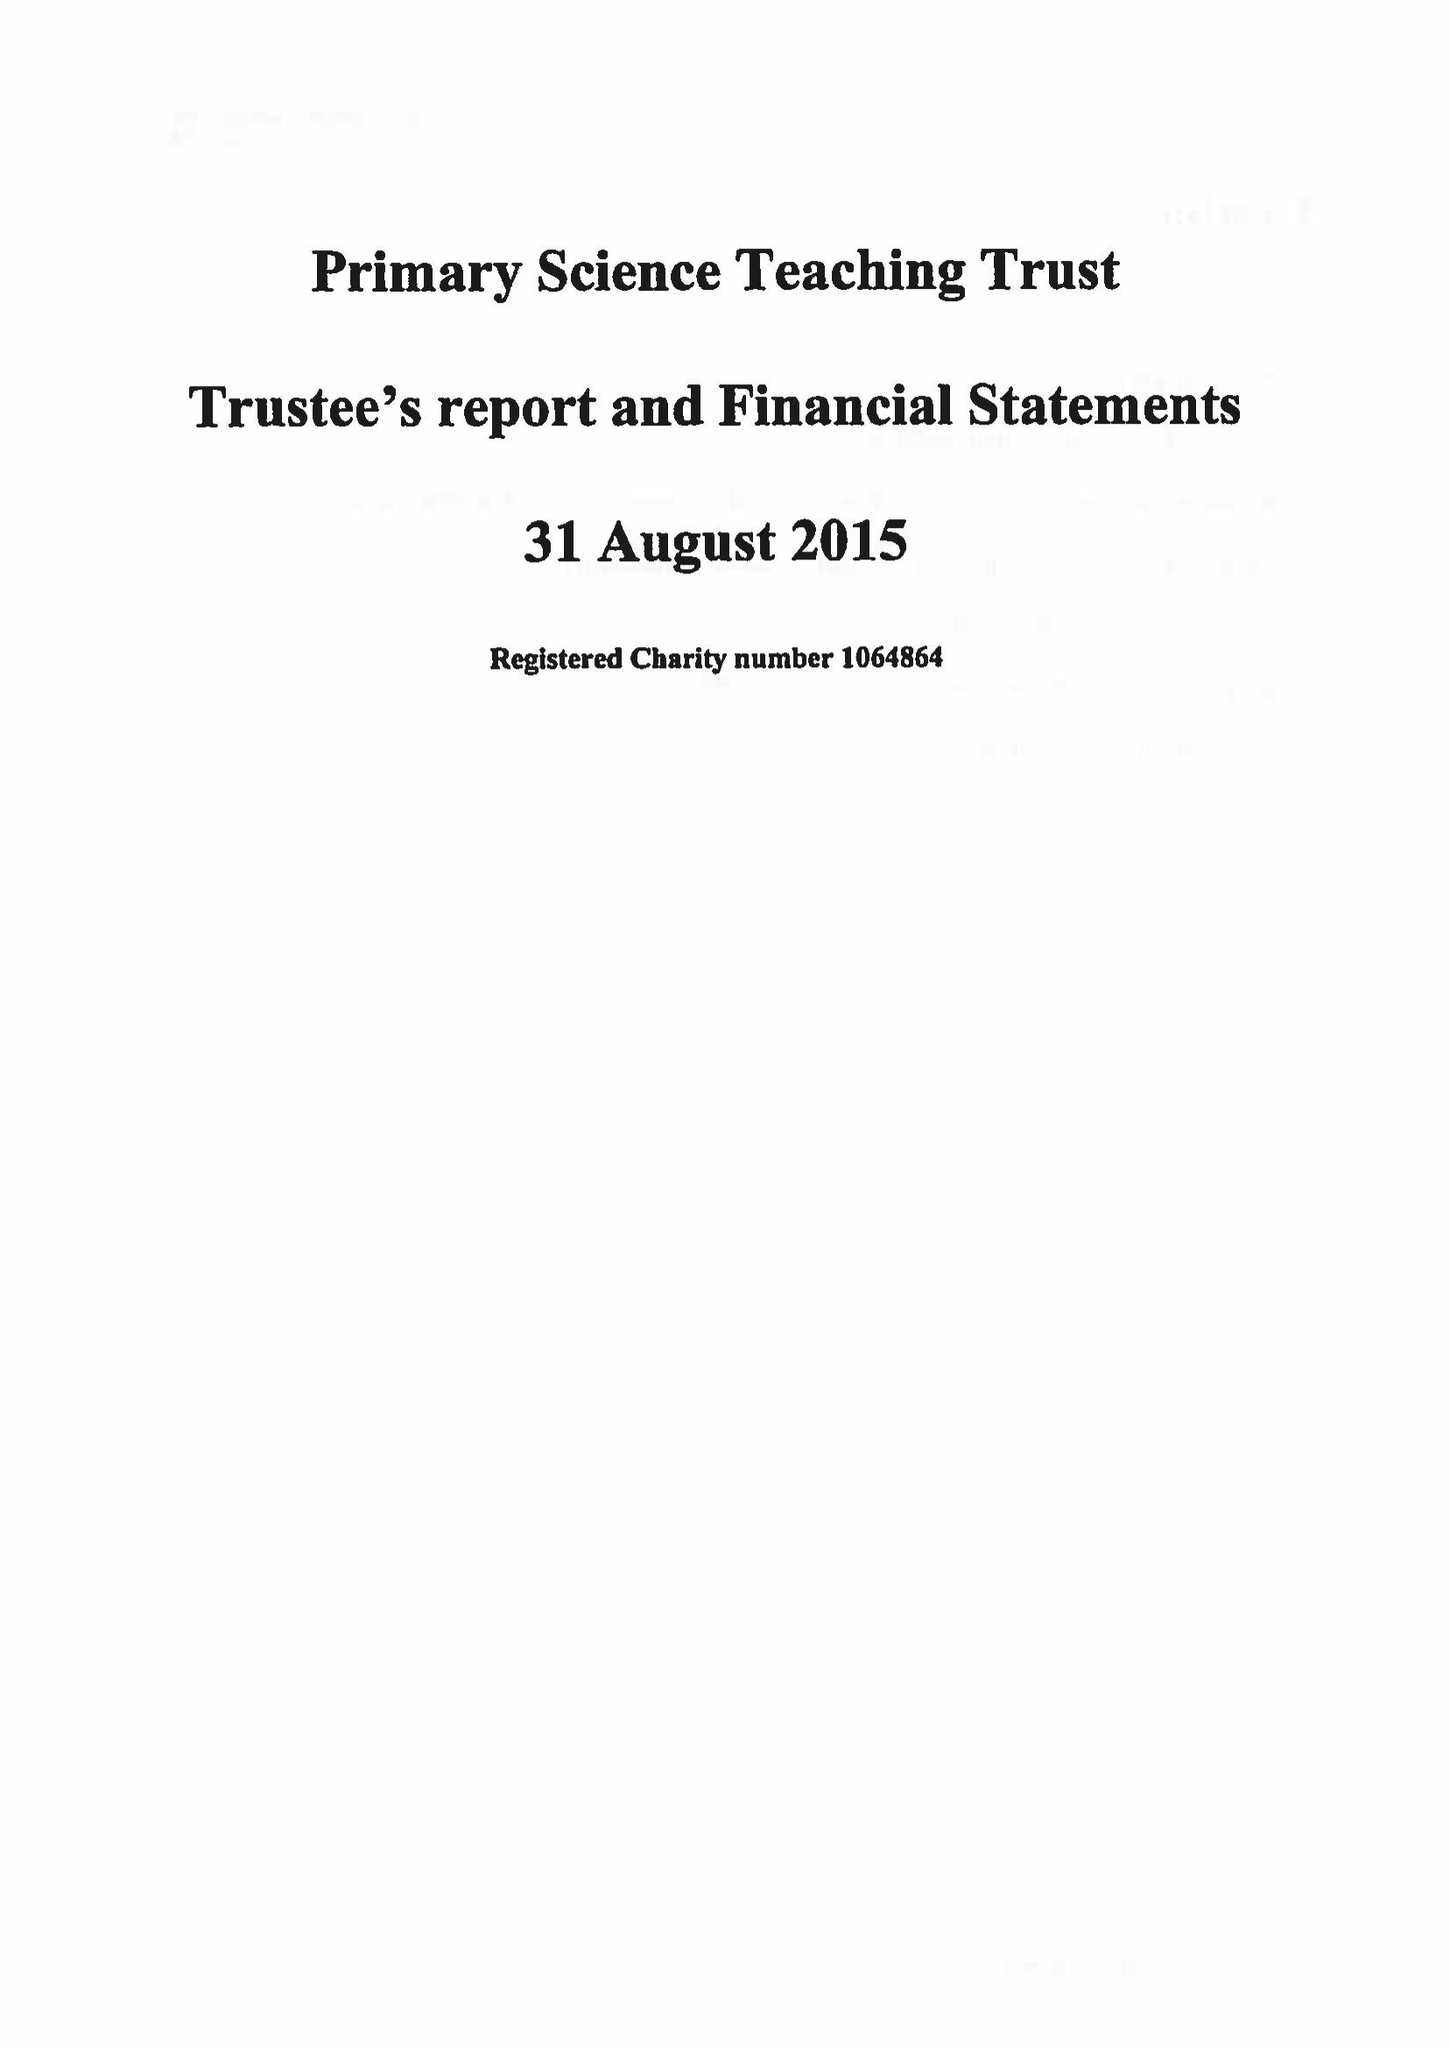What is the value for the charity_name?
Answer the question using a single word or phrase. Primary Science Teaching Trust 